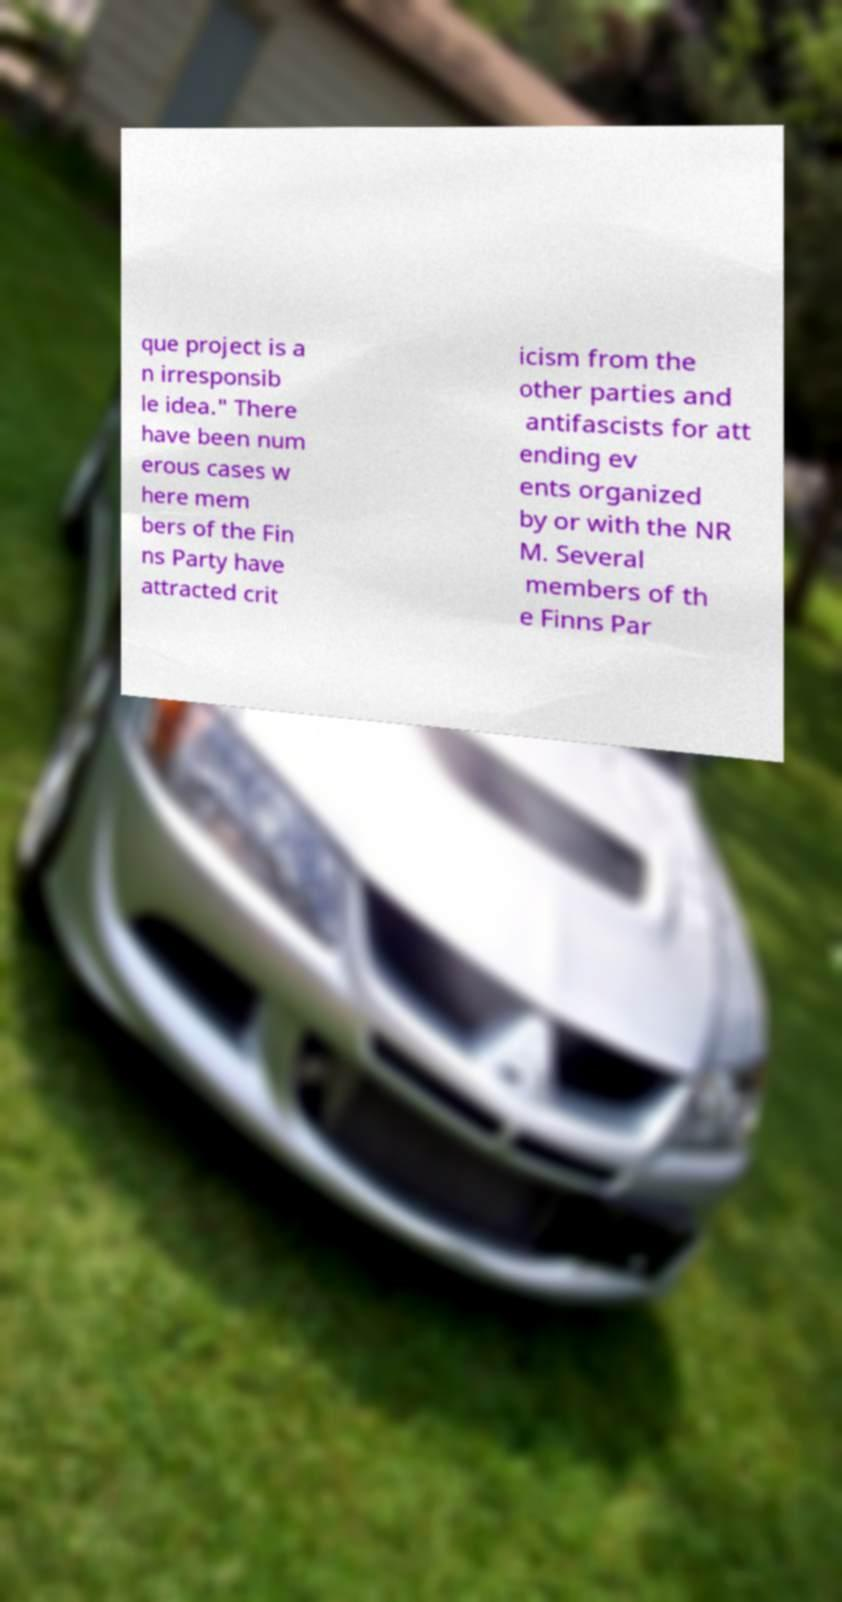I need the written content from this picture converted into text. Can you do that? que project is a n irresponsib le idea." There have been num erous cases w here mem bers of the Fin ns Party have attracted crit icism from the other parties and antifascists for att ending ev ents organized by or with the NR M. Several members of th e Finns Par 